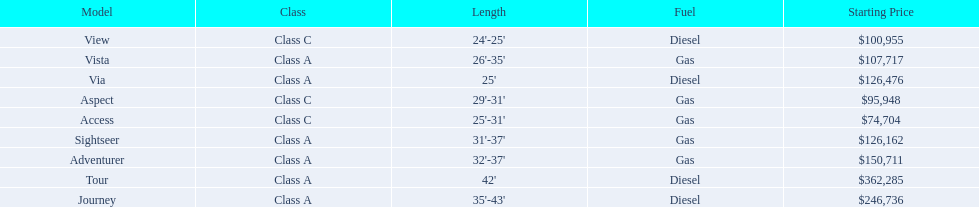Which models are manufactured by winnebago industries? Tour, Journey, Adventurer, Via, Sightseer, Vista, View, Aspect, Access. What type of fuel does each model require? Diesel, Diesel, Gas, Diesel, Gas, Gas, Diesel, Gas, Gas. And between the tour and aspect, which runs on diesel? Tour. 